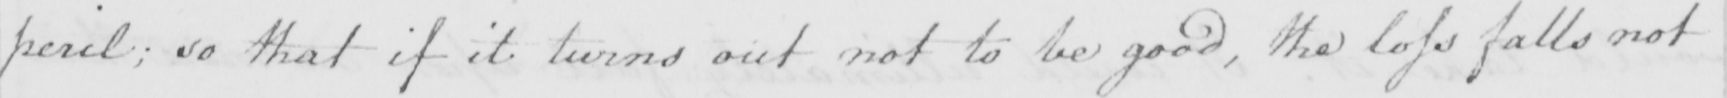Please provide the text content of this handwritten line. peril ; so that if it turns out not to be good , the loss falls not 